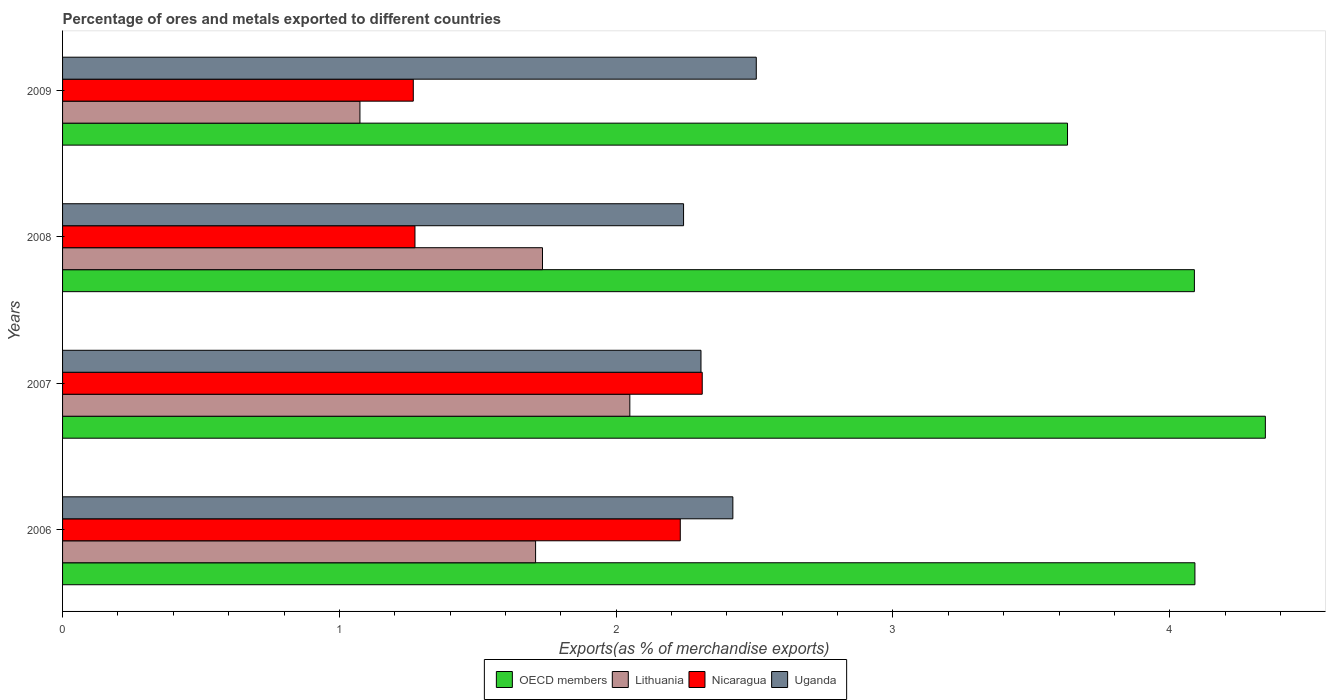How many groups of bars are there?
Keep it short and to the point. 4. Are the number of bars per tick equal to the number of legend labels?
Provide a short and direct response. Yes. How many bars are there on the 3rd tick from the top?
Keep it short and to the point. 4. How many bars are there on the 3rd tick from the bottom?
Offer a terse response. 4. What is the label of the 4th group of bars from the top?
Ensure brevity in your answer.  2006. What is the percentage of exports to different countries in Nicaragua in 2008?
Give a very brief answer. 1.27. Across all years, what is the maximum percentage of exports to different countries in OECD members?
Your answer should be very brief. 4.35. Across all years, what is the minimum percentage of exports to different countries in Nicaragua?
Keep it short and to the point. 1.27. In which year was the percentage of exports to different countries in OECD members minimum?
Offer a terse response. 2009. What is the total percentage of exports to different countries in Uganda in the graph?
Ensure brevity in your answer.  9.48. What is the difference between the percentage of exports to different countries in Nicaragua in 2008 and that in 2009?
Offer a very short reply. 0.01. What is the difference between the percentage of exports to different countries in OECD members in 2008 and the percentage of exports to different countries in Uganda in 2007?
Keep it short and to the point. 1.78. What is the average percentage of exports to different countries in Uganda per year?
Ensure brevity in your answer.  2.37. In the year 2007, what is the difference between the percentage of exports to different countries in OECD members and percentage of exports to different countries in Nicaragua?
Provide a short and direct response. 2.03. What is the ratio of the percentage of exports to different countries in Nicaragua in 2006 to that in 2007?
Your response must be concise. 0.97. Is the percentage of exports to different countries in Uganda in 2007 less than that in 2008?
Provide a short and direct response. No. Is the difference between the percentage of exports to different countries in OECD members in 2007 and 2009 greater than the difference between the percentage of exports to different countries in Nicaragua in 2007 and 2009?
Your answer should be compact. No. What is the difference between the highest and the second highest percentage of exports to different countries in Nicaragua?
Your answer should be very brief. 0.08. What is the difference between the highest and the lowest percentage of exports to different countries in Uganda?
Offer a terse response. 0.26. Is the sum of the percentage of exports to different countries in OECD members in 2007 and 2009 greater than the maximum percentage of exports to different countries in Uganda across all years?
Make the answer very short. Yes. Is it the case that in every year, the sum of the percentage of exports to different countries in Lithuania and percentage of exports to different countries in OECD members is greater than the sum of percentage of exports to different countries in Nicaragua and percentage of exports to different countries in Uganda?
Ensure brevity in your answer.  Yes. What does the 1st bar from the top in 2007 represents?
Provide a short and direct response. Uganda. What does the 3rd bar from the bottom in 2008 represents?
Provide a short and direct response. Nicaragua. Is it the case that in every year, the sum of the percentage of exports to different countries in Uganda and percentage of exports to different countries in OECD members is greater than the percentage of exports to different countries in Nicaragua?
Provide a succinct answer. Yes. Does the graph contain any zero values?
Provide a succinct answer. No. Does the graph contain grids?
Give a very brief answer. No. How many legend labels are there?
Make the answer very short. 4. What is the title of the graph?
Your answer should be very brief. Percentage of ores and metals exported to different countries. What is the label or title of the X-axis?
Your response must be concise. Exports(as % of merchandise exports). What is the Exports(as % of merchandise exports) in OECD members in 2006?
Provide a short and direct response. 4.09. What is the Exports(as % of merchandise exports) in Lithuania in 2006?
Offer a terse response. 1.71. What is the Exports(as % of merchandise exports) in Nicaragua in 2006?
Keep it short and to the point. 2.23. What is the Exports(as % of merchandise exports) in Uganda in 2006?
Offer a terse response. 2.42. What is the Exports(as % of merchandise exports) of OECD members in 2007?
Keep it short and to the point. 4.35. What is the Exports(as % of merchandise exports) of Lithuania in 2007?
Ensure brevity in your answer.  2.05. What is the Exports(as % of merchandise exports) of Nicaragua in 2007?
Keep it short and to the point. 2.31. What is the Exports(as % of merchandise exports) in Uganda in 2007?
Your answer should be compact. 2.31. What is the Exports(as % of merchandise exports) in OECD members in 2008?
Give a very brief answer. 4.09. What is the Exports(as % of merchandise exports) in Lithuania in 2008?
Your response must be concise. 1.73. What is the Exports(as % of merchandise exports) in Nicaragua in 2008?
Give a very brief answer. 1.27. What is the Exports(as % of merchandise exports) of Uganda in 2008?
Your answer should be compact. 2.24. What is the Exports(as % of merchandise exports) in OECD members in 2009?
Provide a succinct answer. 3.63. What is the Exports(as % of merchandise exports) in Lithuania in 2009?
Ensure brevity in your answer.  1.07. What is the Exports(as % of merchandise exports) of Nicaragua in 2009?
Your answer should be very brief. 1.27. What is the Exports(as % of merchandise exports) of Uganda in 2009?
Your answer should be compact. 2.51. Across all years, what is the maximum Exports(as % of merchandise exports) of OECD members?
Ensure brevity in your answer.  4.35. Across all years, what is the maximum Exports(as % of merchandise exports) of Lithuania?
Ensure brevity in your answer.  2.05. Across all years, what is the maximum Exports(as % of merchandise exports) in Nicaragua?
Offer a terse response. 2.31. Across all years, what is the maximum Exports(as % of merchandise exports) of Uganda?
Your answer should be very brief. 2.51. Across all years, what is the minimum Exports(as % of merchandise exports) of OECD members?
Give a very brief answer. 3.63. Across all years, what is the minimum Exports(as % of merchandise exports) in Lithuania?
Provide a short and direct response. 1.07. Across all years, what is the minimum Exports(as % of merchandise exports) of Nicaragua?
Keep it short and to the point. 1.27. Across all years, what is the minimum Exports(as % of merchandise exports) of Uganda?
Provide a succinct answer. 2.24. What is the total Exports(as % of merchandise exports) of OECD members in the graph?
Ensure brevity in your answer.  16.16. What is the total Exports(as % of merchandise exports) of Lithuania in the graph?
Give a very brief answer. 6.57. What is the total Exports(as % of merchandise exports) of Nicaragua in the graph?
Your response must be concise. 7.08. What is the total Exports(as % of merchandise exports) of Uganda in the graph?
Ensure brevity in your answer.  9.48. What is the difference between the Exports(as % of merchandise exports) in OECD members in 2006 and that in 2007?
Your answer should be compact. -0.25. What is the difference between the Exports(as % of merchandise exports) in Lithuania in 2006 and that in 2007?
Provide a succinct answer. -0.34. What is the difference between the Exports(as % of merchandise exports) in Nicaragua in 2006 and that in 2007?
Provide a succinct answer. -0.08. What is the difference between the Exports(as % of merchandise exports) of Uganda in 2006 and that in 2007?
Your response must be concise. 0.12. What is the difference between the Exports(as % of merchandise exports) of OECD members in 2006 and that in 2008?
Provide a succinct answer. 0. What is the difference between the Exports(as % of merchandise exports) in Lithuania in 2006 and that in 2008?
Your response must be concise. -0.02. What is the difference between the Exports(as % of merchandise exports) in Nicaragua in 2006 and that in 2008?
Give a very brief answer. 0.96. What is the difference between the Exports(as % of merchandise exports) in Uganda in 2006 and that in 2008?
Offer a terse response. 0.18. What is the difference between the Exports(as % of merchandise exports) of OECD members in 2006 and that in 2009?
Ensure brevity in your answer.  0.46. What is the difference between the Exports(as % of merchandise exports) in Lithuania in 2006 and that in 2009?
Your answer should be very brief. 0.63. What is the difference between the Exports(as % of merchandise exports) in Nicaragua in 2006 and that in 2009?
Offer a very short reply. 0.96. What is the difference between the Exports(as % of merchandise exports) in Uganda in 2006 and that in 2009?
Ensure brevity in your answer.  -0.08. What is the difference between the Exports(as % of merchandise exports) in OECD members in 2007 and that in 2008?
Offer a terse response. 0.26. What is the difference between the Exports(as % of merchandise exports) in Lithuania in 2007 and that in 2008?
Your answer should be very brief. 0.32. What is the difference between the Exports(as % of merchandise exports) of Nicaragua in 2007 and that in 2008?
Provide a succinct answer. 1.04. What is the difference between the Exports(as % of merchandise exports) of Uganda in 2007 and that in 2008?
Make the answer very short. 0.06. What is the difference between the Exports(as % of merchandise exports) in OECD members in 2007 and that in 2009?
Your answer should be compact. 0.71. What is the difference between the Exports(as % of merchandise exports) in Lithuania in 2007 and that in 2009?
Provide a short and direct response. 0.97. What is the difference between the Exports(as % of merchandise exports) of Nicaragua in 2007 and that in 2009?
Ensure brevity in your answer.  1.04. What is the difference between the Exports(as % of merchandise exports) in Uganda in 2007 and that in 2009?
Your response must be concise. -0.2. What is the difference between the Exports(as % of merchandise exports) of OECD members in 2008 and that in 2009?
Give a very brief answer. 0.46. What is the difference between the Exports(as % of merchandise exports) in Lithuania in 2008 and that in 2009?
Keep it short and to the point. 0.66. What is the difference between the Exports(as % of merchandise exports) of Nicaragua in 2008 and that in 2009?
Ensure brevity in your answer.  0.01. What is the difference between the Exports(as % of merchandise exports) in Uganda in 2008 and that in 2009?
Your response must be concise. -0.26. What is the difference between the Exports(as % of merchandise exports) of OECD members in 2006 and the Exports(as % of merchandise exports) of Lithuania in 2007?
Provide a succinct answer. 2.04. What is the difference between the Exports(as % of merchandise exports) of OECD members in 2006 and the Exports(as % of merchandise exports) of Nicaragua in 2007?
Keep it short and to the point. 1.78. What is the difference between the Exports(as % of merchandise exports) of OECD members in 2006 and the Exports(as % of merchandise exports) of Uganda in 2007?
Provide a short and direct response. 1.78. What is the difference between the Exports(as % of merchandise exports) in Lithuania in 2006 and the Exports(as % of merchandise exports) in Nicaragua in 2007?
Keep it short and to the point. -0.6. What is the difference between the Exports(as % of merchandise exports) of Lithuania in 2006 and the Exports(as % of merchandise exports) of Uganda in 2007?
Provide a succinct answer. -0.6. What is the difference between the Exports(as % of merchandise exports) in Nicaragua in 2006 and the Exports(as % of merchandise exports) in Uganda in 2007?
Keep it short and to the point. -0.07. What is the difference between the Exports(as % of merchandise exports) in OECD members in 2006 and the Exports(as % of merchandise exports) in Lithuania in 2008?
Your answer should be very brief. 2.36. What is the difference between the Exports(as % of merchandise exports) of OECD members in 2006 and the Exports(as % of merchandise exports) of Nicaragua in 2008?
Your answer should be compact. 2.82. What is the difference between the Exports(as % of merchandise exports) of OECD members in 2006 and the Exports(as % of merchandise exports) of Uganda in 2008?
Offer a terse response. 1.85. What is the difference between the Exports(as % of merchandise exports) of Lithuania in 2006 and the Exports(as % of merchandise exports) of Nicaragua in 2008?
Give a very brief answer. 0.44. What is the difference between the Exports(as % of merchandise exports) in Lithuania in 2006 and the Exports(as % of merchandise exports) in Uganda in 2008?
Your response must be concise. -0.53. What is the difference between the Exports(as % of merchandise exports) in Nicaragua in 2006 and the Exports(as % of merchandise exports) in Uganda in 2008?
Offer a very short reply. -0.01. What is the difference between the Exports(as % of merchandise exports) of OECD members in 2006 and the Exports(as % of merchandise exports) of Lithuania in 2009?
Provide a succinct answer. 3.02. What is the difference between the Exports(as % of merchandise exports) of OECD members in 2006 and the Exports(as % of merchandise exports) of Nicaragua in 2009?
Provide a succinct answer. 2.82. What is the difference between the Exports(as % of merchandise exports) in OECD members in 2006 and the Exports(as % of merchandise exports) in Uganda in 2009?
Make the answer very short. 1.58. What is the difference between the Exports(as % of merchandise exports) in Lithuania in 2006 and the Exports(as % of merchandise exports) in Nicaragua in 2009?
Ensure brevity in your answer.  0.44. What is the difference between the Exports(as % of merchandise exports) of Lithuania in 2006 and the Exports(as % of merchandise exports) of Uganda in 2009?
Ensure brevity in your answer.  -0.8. What is the difference between the Exports(as % of merchandise exports) of Nicaragua in 2006 and the Exports(as % of merchandise exports) of Uganda in 2009?
Your answer should be compact. -0.27. What is the difference between the Exports(as % of merchandise exports) in OECD members in 2007 and the Exports(as % of merchandise exports) in Lithuania in 2008?
Your answer should be compact. 2.61. What is the difference between the Exports(as % of merchandise exports) in OECD members in 2007 and the Exports(as % of merchandise exports) in Nicaragua in 2008?
Offer a terse response. 3.07. What is the difference between the Exports(as % of merchandise exports) of OECD members in 2007 and the Exports(as % of merchandise exports) of Uganda in 2008?
Your answer should be compact. 2.1. What is the difference between the Exports(as % of merchandise exports) of Lithuania in 2007 and the Exports(as % of merchandise exports) of Nicaragua in 2008?
Provide a succinct answer. 0.78. What is the difference between the Exports(as % of merchandise exports) in Lithuania in 2007 and the Exports(as % of merchandise exports) in Uganda in 2008?
Give a very brief answer. -0.19. What is the difference between the Exports(as % of merchandise exports) in Nicaragua in 2007 and the Exports(as % of merchandise exports) in Uganda in 2008?
Your response must be concise. 0.07. What is the difference between the Exports(as % of merchandise exports) in OECD members in 2007 and the Exports(as % of merchandise exports) in Lithuania in 2009?
Ensure brevity in your answer.  3.27. What is the difference between the Exports(as % of merchandise exports) of OECD members in 2007 and the Exports(as % of merchandise exports) of Nicaragua in 2009?
Give a very brief answer. 3.08. What is the difference between the Exports(as % of merchandise exports) of OECD members in 2007 and the Exports(as % of merchandise exports) of Uganda in 2009?
Your response must be concise. 1.84. What is the difference between the Exports(as % of merchandise exports) of Lithuania in 2007 and the Exports(as % of merchandise exports) of Nicaragua in 2009?
Ensure brevity in your answer.  0.78. What is the difference between the Exports(as % of merchandise exports) of Lithuania in 2007 and the Exports(as % of merchandise exports) of Uganda in 2009?
Keep it short and to the point. -0.46. What is the difference between the Exports(as % of merchandise exports) of Nicaragua in 2007 and the Exports(as % of merchandise exports) of Uganda in 2009?
Your response must be concise. -0.2. What is the difference between the Exports(as % of merchandise exports) of OECD members in 2008 and the Exports(as % of merchandise exports) of Lithuania in 2009?
Provide a succinct answer. 3.01. What is the difference between the Exports(as % of merchandise exports) of OECD members in 2008 and the Exports(as % of merchandise exports) of Nicaragua in 2009?
Provide a succinct answer. 2.82. What is the difference between the Exports(as % of merchandise exports) in OECD members in 2008 and the Exports(as % of merchandise exports) in Uganda in 2009?
Your answer should be compact. 1.58. What is the difference between the Exports(as % of merchandise exports) in Lithuania in 2008 and the Exports(as % of merchandise exports) in Nicaragua in 2009?
Make the answer very short. 0.47. What is the difference between the Exports(as % of merchandise exports) of Lithuania in 2008 and the Exports(as % of merchandise exports) of Uganda in 2009?
Offer a terse response. -0.77. What is the difference between the Exports(as % of merchandise exports) in Nicaragua in 2008 and the Exports(as % of merchandise exports) in Uganda in 2009?
Provide a succinct answer. -1.23. What is the average Exports(as % of merchandise exports) in OECD members per year?
Your response must be concise. 4.04. What is the average Exports(as % of merchandise exports) of Lithuania per year?
Your answer should be very brief. 1.64. What is the average Exports(as % of merchandise exports) in Nicaragua per year?
Keep it short and to the point. 1.77. What is the average Exports(as % of merchandise exports) of Uganda per year?
Your answer should be compact. 2.37. In the year 2006, what is the difference between the Exports(as % of merchandise exports) of OECD members and Exports(as % of merchandise exports) of Lithuania?
Make the answer very short. 2.38. In the year 2006, what is the difference between the Exports(as % of merchandise exports) in OECD members and Exports(as % of merchandise exports) in Nicaragua?
Your answer should be compact. 1.86. In the year 2006, what is the difference between the Exports(as % of merchandise exports) of OECD members and Exports(as % of merchandise exports) of Uganda?
Provide a short and direct response. 1.67. In the year 2006, what is the difference between the Exports(as % of merchandise exports) in Lithuania and Exports(as % of merchandise exports) in Nicaragua?
Your answer should be very brief. -0.52. In the year 2006, what is the difference between the Exports(as % of merchandise exports) of Lithuania and Exports(as % of merchandise exports) of Uganda?
Offer a terse response. -0.71. In the year 2006, what is the difference between the Exports(as % of merchandise exports) of Nicaragua and Exports(as % of merchandise exports) of Uganda?
Give a very brief answer. -0.19. In the year 2007, what is the difference between the Exports(as % of merchandise exports) of OECD members and Exports(as % of merchandise exports) of Lithuania?
Give a very brief answer. 2.3. In the year 2007, what is the difference between the Exports(as % of merchandise exports) of OECD members and Exports(as % of merchandise exports) of Nicaragua?
Make the answer very short. 2.03. In the year 2007, what is the difference between the Exports(as % of merchandise exports) of OECD members and Exports(as % of merchandise exports) of Uganda?
Provide a succinct answer. 2.04. In the year 2007, what is the difference between the Exports(as % of merchandise exports) of Lithuania and Exports(as % of merchandise exports) of Nicaragua?
Offer a very short reply. -0.26. In the year 2007, what is the difference between the Exports(as % of merchandise exports) of Lithuania and Exports(as % of merchandise exports) of Uganda?
Offer a very short reply. -0.26. In the year 2007, what is the difference between the Exports(as % of merchandise exports) of Nicaragua and Exports(as % of merchandise exports) of Uganda?
Your answer should be compact. 0. In the year 2008, what is the difference between the Exports(as % of merchandise exports) of OECD members and Exports(as % of merchandise exports) of Lithuania?
Give a very brief answer. 2.36. In the year 2008, what is the difference between the Exports(as % of merchandise exports) of OECD members and Exports(as % of merchandise exports) of Nicaragua?
Offer a terse response. 2.82. In the year 2008, what is the difference between the Exports(as % of merchandise exports) of OECD members and Exports(as % of merchandise exports) of Uganda?
Your answer should be compact. 1.85. In the year 2008, what is the difference between the Exports(as % of merchandise exports) of Lithuania and Exports(as % of merchandise exports) of Nicaragua?
Make the answer very short. 0.46. In the year 2008, what is the difference between the Exports(as % of merchandise exports) in Lithuania and Exports(as % of merchandise exports) in Uganda?
Make the answer very short. -0.51. In the year 2008, what is the difference between the Exports(as % of merchandise exports) of Nicaragua and Exports(as % of merchandise exports) of Uganda?
Offer a very short reply. -0.97. In the year 2009, what is the difference between the Exports(as % of merchandise exports) of OECD members and Exports(as % of merchandise exports) of Lithuania?
Give a very brief answer. 2.56. In the year 2009, what is the difference between the Exports(as % of merchandise exports) in OECD members and Exports(as % of merchandise exports) in Nicaragua?
Offer a terse response. 2.36. In the year 2009, what is the difference between the Exports(as % of merchandise exports) in OECD members and Exports(as % of merchandise exports) in Uganda?
Your answer should be very brief. 1.12. In the year 2009, what is the difference between the Exports(as % of merchandise exports) in Lithuania and Exports(as % of merchandise exports) in Nicaragua?
Ensure brevity in your answer.  -0.19. In the year 2009, what is the difference between the Exports(as % of merchandise exports) of Lithuania and Exports(as % of merchandise exports) of Uganda?
Give a very brief answer. -1.43. In the year 2009, what is the difference between the Exports(as % of merchandise exports) of Nicaragua and Exports(as % of merchandise exports) of Uganda?
Provide a short and direct response. -1.24. What is the ratio of the Exports(as % of merchandise exports) in OECD members in 2006 to that in 2007?
Offer a very short reply. 0.94. What is the ratio of the Exports(as % of merchandise exports) of Lithuania in 2006 to that in 2007?
Make the answer very short. 0.83. What is the ratio of the Exports(as % of merchandise exports) of Nicaragua in 2006 to that in 2007?
Make the answer very short. 0.97. What is the ratio of the Exports(as % of merchandise exports) in Uganda in 2006 to that in 2007?
Keep it short and to the point. 1.05. What is the ratio of the Exports(as % of merchandise exports) of Lithuania in 2006 to that in 2008?
Offer a very short reply. 0.99. What is the ratio of the Exports(as % of merchandise exports) in Nicaragua in 2006 to that in 2008?
Your answer should be compact. 1.75. What is the ratio of the Exports(as % of merchandise exports) in Uganda in 2006 to that in 2008?
Make the answer very short. 1.08. What is the ratio of the Exports(as % of merchandise exports) in OECD members in 2006 to that in 2009?
Offer a very short reply. 1.13. What is the ratio of the Exports(as % of merchandise exports) in Lithuania in 2006 to that in 2009?
Make the answer very short. 1.59. What is the ratio of the Exports(as % of merchandise exports) in Nicaragua in 2006 to that in 2009?
Provide a short and direct response. 1.76. What is the ratio of the Exports(as % of merchandise exports) in Uganda in 2006 to that in 2009?
Your answer should be very brief. 0.97. What is the ratio of the Exports(as % of merchandise exports) in OECD members in 2007 to that in 2008?
Your answer should be compact. 1.06. What is the ratio of the Exports(as % of merchandise exports) of Lithuania in 2007 to that in 2008?
Ensure brevity in your answer.  1.18. What is the ratio of the Exports(as % of merchandise exports) of Nicaragua in 2007 to that in 2008?
Your answer should be compact. 1.82. What is the ratio of the Exports(as % of merchandise exports) in Uganda in 2007 to that in 2008?
Your answer should be very brief. 1.03. What is the ratio of the Exports(as % of merchandise exports) in OECD members in 2007 to that in 2009?
Your answer should be very brief. 1.2. What is the ratio of the Exports(as % of merchandise exports) of Lithuania in 2007 to that in 2009?
Provide a succinct answer. 1.91. What is the ratio of the Exports(as % of merchandise exports) in Nicaragua in 2007 to that in 2009?
Make the answer very short. 1.82. What is the ratio of the Exports(as % of merchandise exports) of Uganda in 2007 to that in 2009?
Ensure brevity in your answer.  0.92. What is the ratio of the Exports(as % of merchandise exports) of OECD members in 2008 to that in 2009?
Your answer should be compact. 1.13. What is the ratio of the Exports(as % of merchandise exports) of Lithuania in 2008 to that in 2009?
Provide a succinct answer. 1.61. What is the ratio of the Exports(as % of merchandise exports) in Nicaragua in 2008 to that in 2009?
Your answer should be compact. 1. What is the ratio of the Exports(as % of merchandise exports) of Uganda in 2008 to that in 2009?
Keep it short and to the point. 0.9. What is the difference between the highest and the second highest Exports(as % of merchandise exports) in OECD members?
Provide a succinct answer. 0.25. What is the difference between the highest and the second highest Exports(as % of merchandise exports) of Lithuania?
Your response must be concise. 0.32. What is the difference between the highest and the second highest Exports(as % of merchandise exports) in Nicaragua?
Ensure brevity in your answer.  0.08. What is the difference between the highest and the second highest Exports(as % of merchandise exports) in Uganda?
Your response must be concise. 0.08. What is the difference between the highest and the lowest Exports(as % of merchandise exports) in OECD members?
Offer a very short reply. 0.71. What is the difference between the highest and the lowest Exports(as % of merchandise exports) of Lithuania?
Provide a succinct answer. 0.97. What is the difference between the highest and the lowest Exports(as % of merchandise exports) of Nicaragua?
Provide a succinct answer. 1.04. What is the difference between the highest and the lowest Exports(as % of merchandise exports) in Uganda?
Provide a short and direct response. 0.26. 